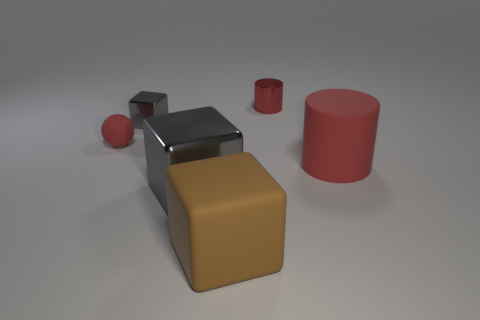What number of red objects are either big matte cubes or small shiny cylinders?
Your answer should be very brief. 1. Is the number of shiny objects that are in front of the big red rubber cylinder greater than the number of blue shiny blocks?
Offer a terse response. Yes. Do the matte block and the red shiny cylinder have the same size?
Keep it short and to the point. No. There is a cube that is made of the same material as the big red object; what is its color?
Give a very brief answer. Brown. What is the shape of the large thing that is the same color as the tiny cylinder?
Give a very brief answer. Cylinder. Are there an equal number of small cylinders behind the shiny cylinder and things that are in front of the tiny red sphere?
Your response must be concise. No. There is a gray shiny thing that is behind the big object that is left of the brown rubber block; what shape is it?
Your answer should be very brief. Cube. What is the material of the other thing that is the same shape as the red metal thing?
Your answer should be compact. Rubber. What is the color of the shiny cylinder that is the same size as the red rubber ball?
Keep it short and to the point. Red. Is the number of large matte objects to the right of the rubber cylinder the same as the number of blue balls?
Your response must be concise. Yes. 